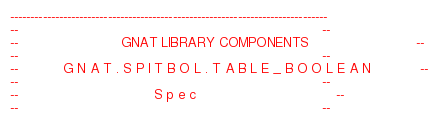Convert code to text. <code><loc_0><loc_0><loc_500><loc_500><_Ada_>------------------------------------------------------------------------------
--                                                                          --
--                         GNAT LIBRARY COMPONENTS                          --
--                                                                          --
--           G N A T . S P I T B O L . T A B L E _ B O O L E A N            --
--                                                                          --
--                                 S p e c                                  --
--                                                                          --</code> 